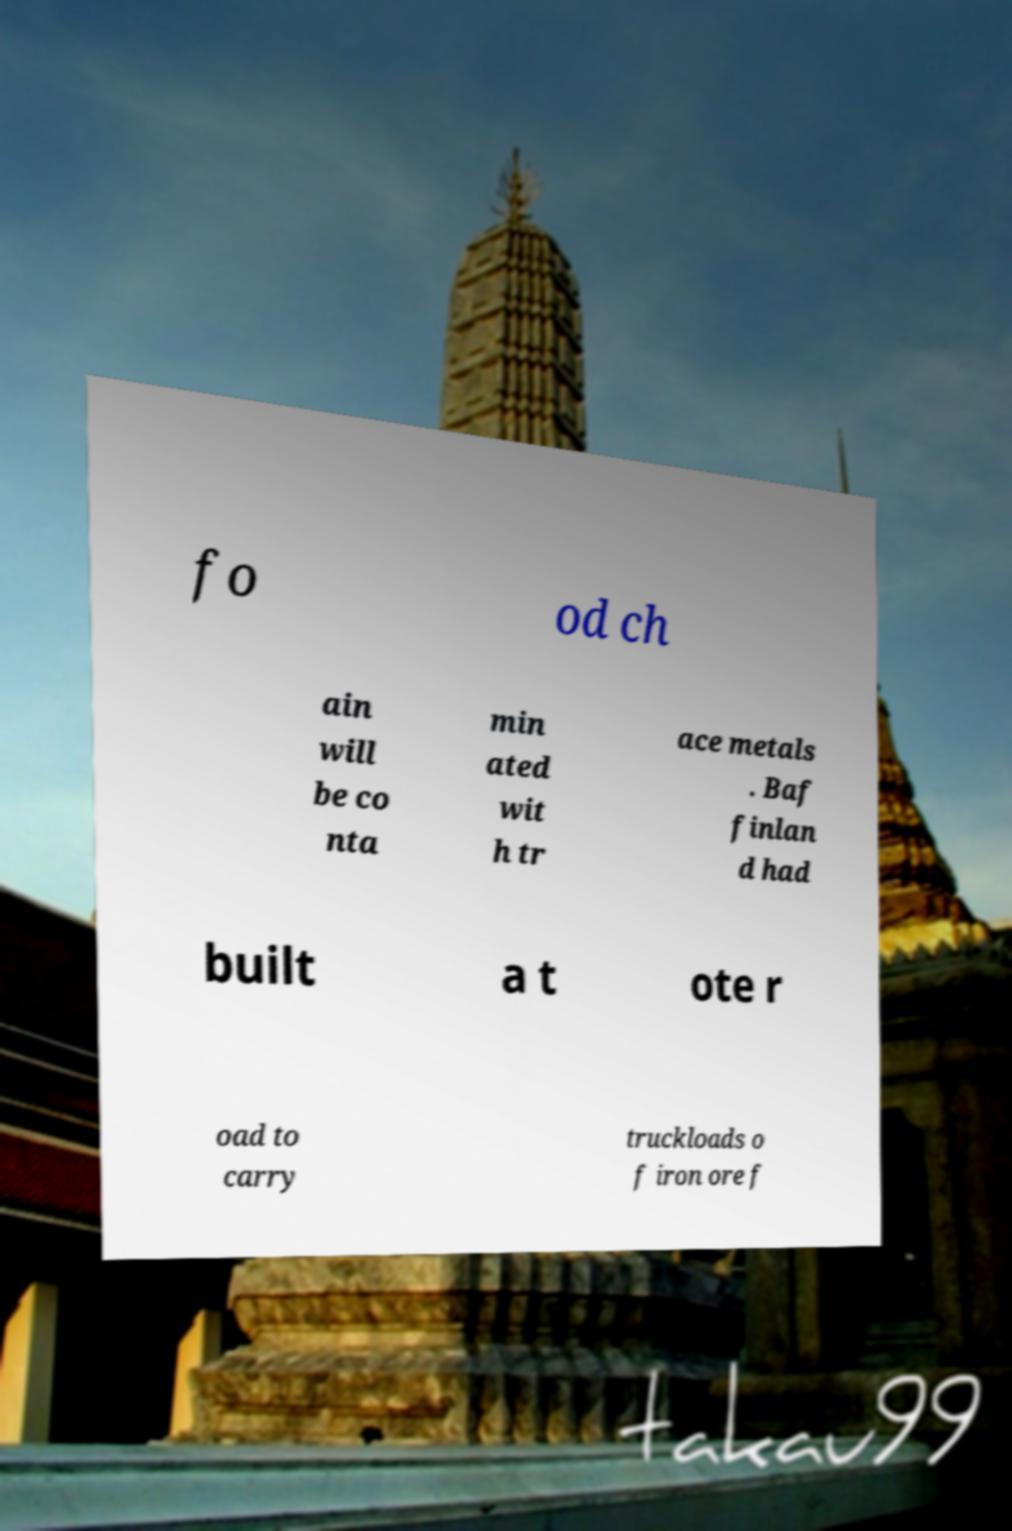Can you accurately transcribe the text from the provided image for me? fo od ch ain will be co nta min ated wit h tr ace metals . Baf finlan d had built a t ote r oad to carry truckloads o f iron ore f 